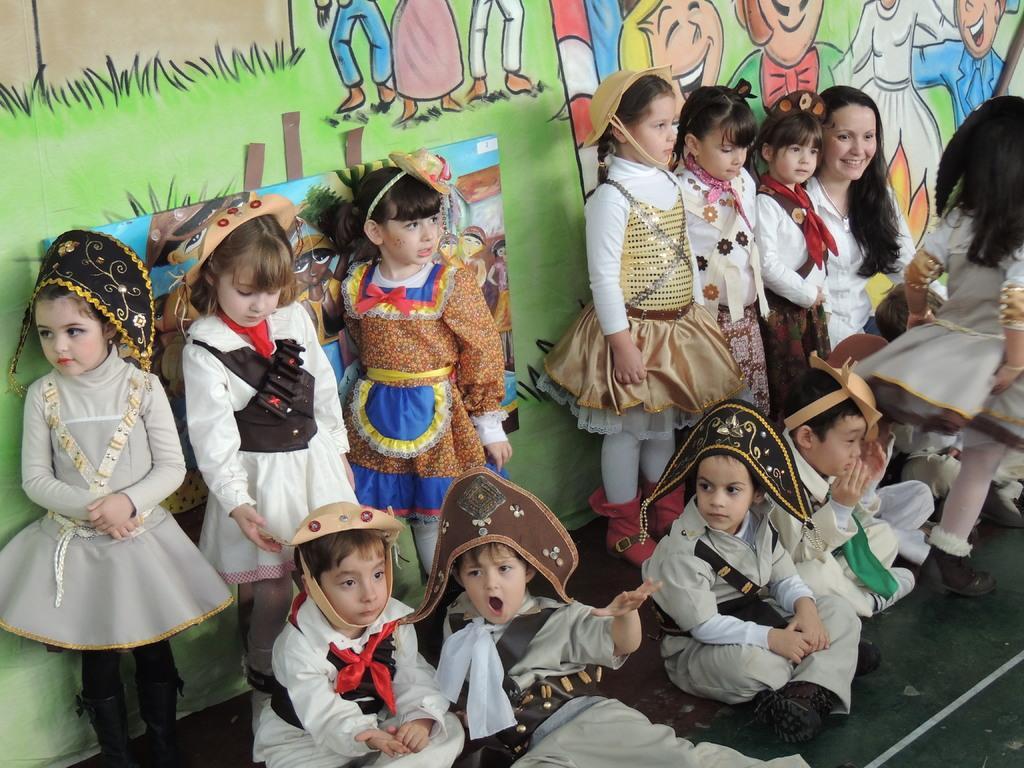How would you summarize this image in a sentence or two? In this image there are group of kids sitting, and there are group of kids standing, and in the background there are paintings on the wall. 